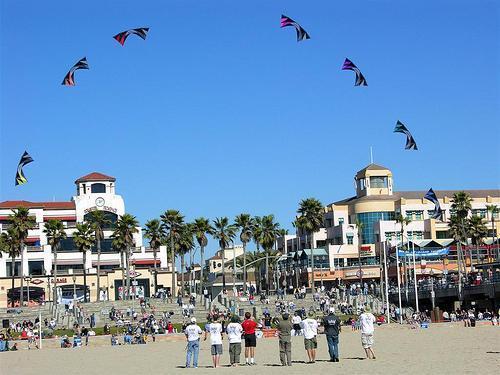How many people are wearing shorts in the forefront of this photo?
Give a very brief answer. 4. 